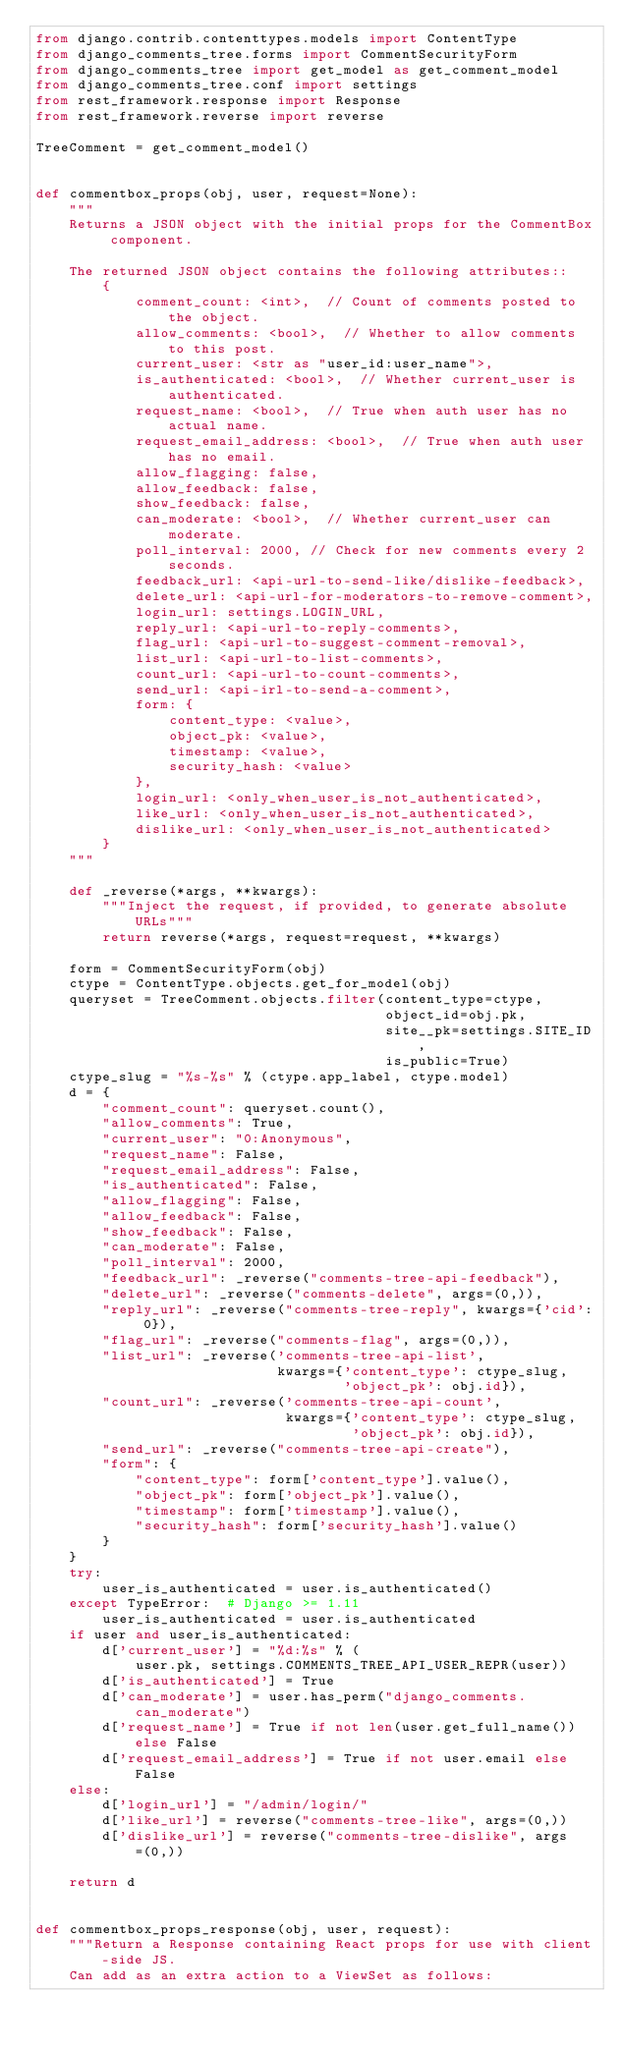Convert code to text. <code><loc_0><loc_0><loc_500><loc_500><_Python_>from django.contrib.contenttypes.models import ContentType
from django_comments_tree.forms import CommentSecurityForm
from django_comments_tree import get_model as get_comment_model
from django_comments_tree.conf import settings
from rest_framework.response import Response
from rest_framework.reverse import reverse

TreeComment = get_comment_model()


def commentbox_props(obj, user, request=None):
    """
    Returns a JSON object with the initial props for the CommentBox component.

    The returned JSON object contains the following attributes::
        {
            comment_count: <int>,  // Count of comments posted to the object.
            allow_comments: <bool>,  // Whether to allow comments to this post.
            current_user: <str as "user_id:user_name">,
            is_authenticated: <bool>,  // Whether current_user is authenticated.
            request_name: <bool>,  // True when auth user has no actual name.
            request_email_address: <bool>,  // True when auth user has no email.
            allow_flagging: false,
            allow_feedback: false,
            show_feedback: false,
            can_moderate: <bool>,  // Whether current_user can moderate.
            poll_interval: 2000, // Check for new comments every 2 seconds.
            feedback_url: <api-url-to-send-like/dislike-feedback>,
            delete_url: <api-url-for-moderators-to-remove-comment>,
            login_url: settings.LOGIN_URL,
            reply_url: <api-url-to-reply-comments>,
            flag_url: <api-url-to-suggest-comment-removal>,
            list_url: <api-url-to-list-comments>,
            count_url: <api-url-to-count-comments>,
            send_url: <api-irl-to-send-a-comment>,
            form: {
                content_type: <value>,
                object_pk: <value>,
                timestamp: <value>,
                security_hash: <value>
            },
            login_url: <only_when_user_is_not_authenticated>,
            like_url: <only_when_user_is_not_authenticated>,
            dislike_url: <only_when_user_is_not_authenticated>
        }
    """

    def _reverse(*args, **kwargs):
        """Inject the request, if provided, to generate absolute URLs"""
        return reverse(*args, request=request, **kwargs)

    form = CommentSecurityForm(obj)
    ctype = ContentType.objects.get_for_model(obj)
    queryset = TreeComment.objects.filter(content_type=ctype,
                                          object_id=obj.pk,
                                          site__pk=settings.SITE_ID,
                                          is_public=True)
    ctype_slug = "%s-%s" % (ctype.app_label, ctype.model)
    d = {
        "comment_count": queryset.count(),
        "allow_comments": True,
        "current_user": "0:Anonymous",
        "request_name": False,
        "request_email_address": False,
        "is_authenticated": False,
        "allow_flagging": False,
        "allow_feedback": False,
        "show_feedback": False,
        "can_moderate": False,
        "poll_interval": 2000,
        "feedback_url": _reverse("comments-tree-api-feedback"),
        "delete_url": _reverse("comments-delete", args=(0,)),
        "reply_url": _reverse("comments-tree-reply", kwargs={'cid': 0}),
        "flag_url": _reverse("comments-flag", args=(0,)),
        "list_url": _reverse('comments-tree-api-list',
                             kwargs={'content_type': ctype_slug,
                                     'object_pk': obj.id}),
        "count_url": _reverse('comments-tree-api-count',
                              kwargs={'content_type': ctype_slug,
                                      'object_pk': obj.id}),
        "send_url": _reverse("comments-tree-api-create"),
        "form": {
            "content_type": form['content_type'].value(),
            "object_pk": form['object_pk'].value(),
            "timestamp": form['timestamp'].value(),
            "security_hash": form['security_hash'].value()
        }
    }
    try:
        user_is_authenticated = user.is_authenticated()
    except TypeError:  # Django >= 1.11
        user_is_authenticated = user.is_authenticated
    if user and user_is_authenticated:
        d['current_user'] = "%d:%s" % (
            user.pk, settings.COMMENTS_TREE_API_USER_REPR(user))
        d['is_authenticated'] = True
        d['can_moderate'] = user.has_perm("django_comments.can_moderate")
        d['request_name'] = True if not len(user.get_full_name()) else False
        d['request_email_address'] = True if not user.email else False
    else:
        d['login_url'] = "/admin/login/"
        d['like_url'] = reverse("comments-tree-like", args=(0,))
        d['dislike_url'] = reverse("comments-tree-dislike", args=(0,))

    return d


def commentbox_props_response(obj, user, request):
    """Return a Response containing React props for use with client-side JS.
    Can add as an extra action to a ViewSet as follows:
</code> 